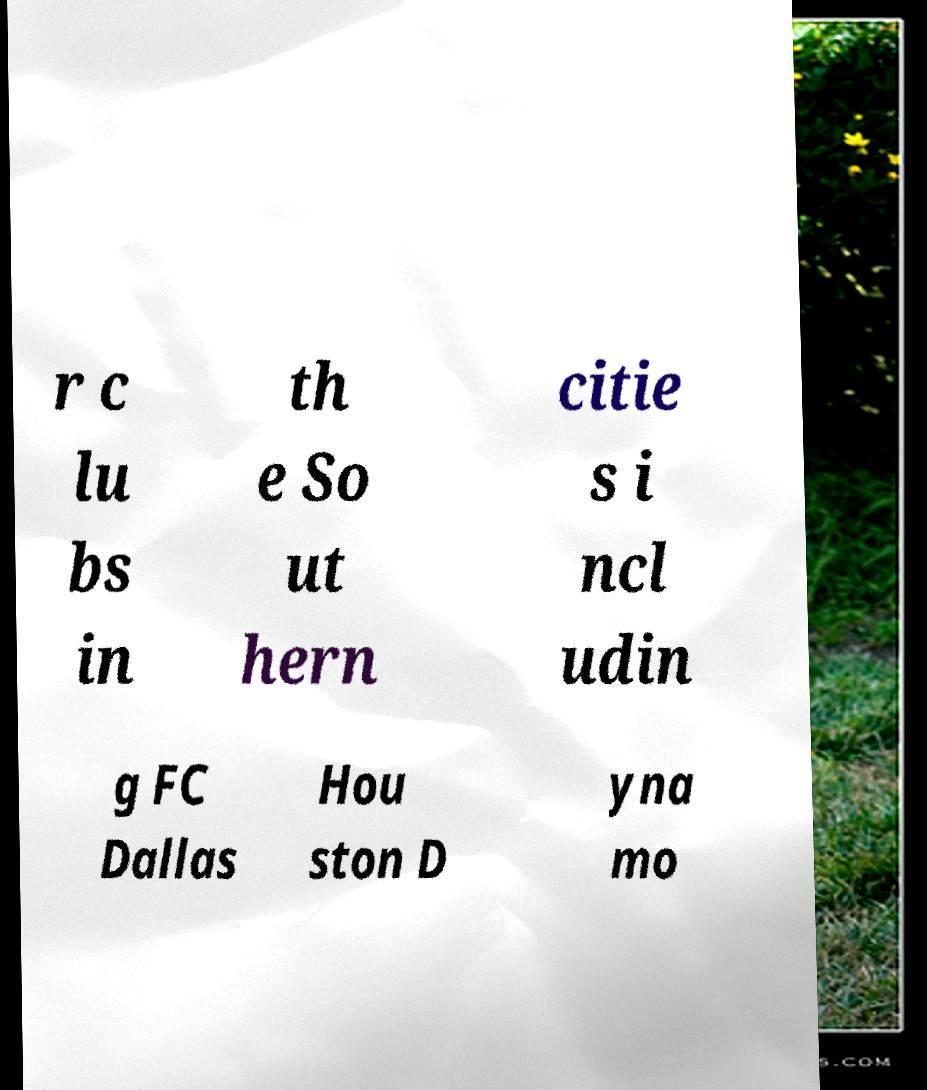Can you read and provide the text displayed in the image?This photo seems to have some interesting text. Can you extract and type it out for me? r c lu bs in th e So ut hern citie s i ncl udin g FC Dallas Hou ston D yna mo 